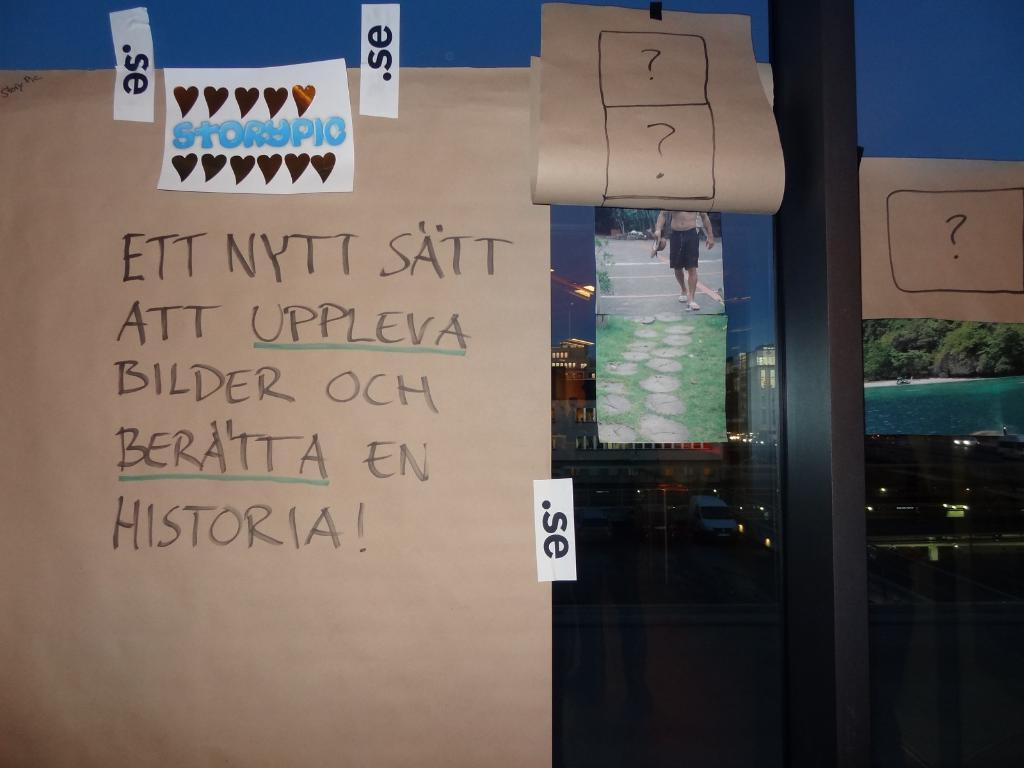What is present on the paper in the image? The provided facts do not mention any details about the paper in the image. What is attached to the glass in the image? Images and stickers are attached to the glass in the image. Can you see a river flowing through the image? There is no mention of a river in the provided facts, and therefore no such feature can be observed in the image. 